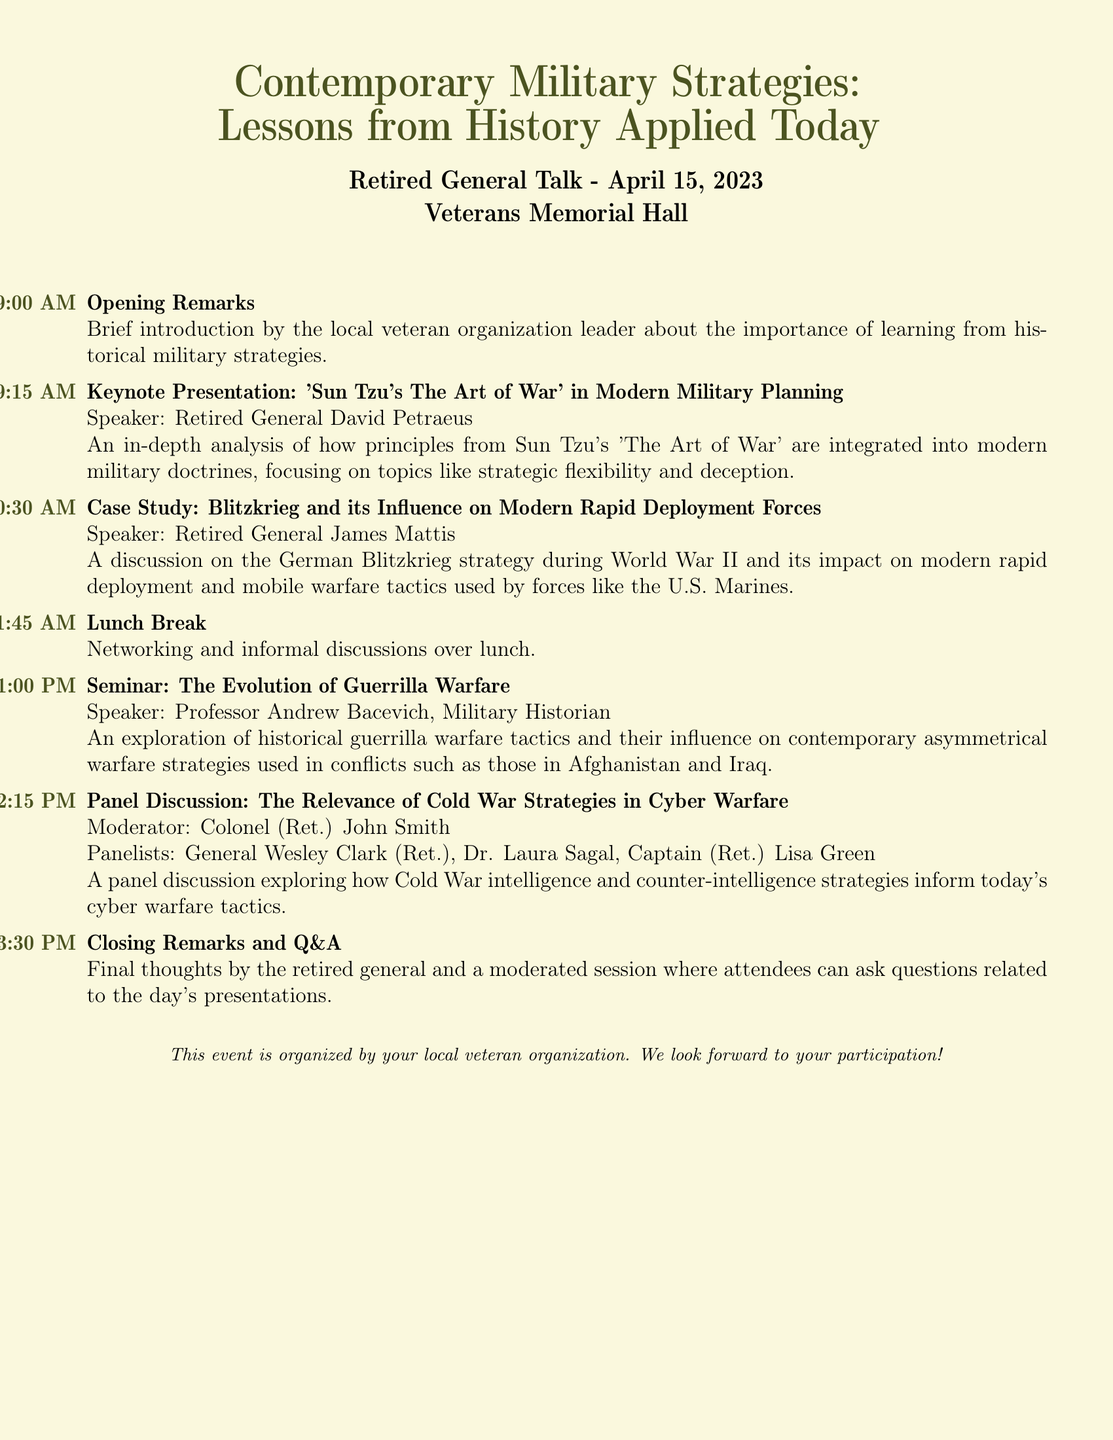What is the date of the event? The date is mentioned prominently in the document, indicating when the event will take place.
Answer: April 15, 2023 Who is the keynote speaker? The document lists the keynote presentation and its speaker, providing specific names associated with each segment.
Answer: Retired General David Petraeus What time does the panel discussion start? The document provides a detailed schedule with exact times for each event.
Answer: 02:15 PM Which strategy is discussed in the case study session? The case study section mentions the specific historical strategy being analyzed during that segment.
Answer: Blitzkrieg Who moderates the panel discussion? The document specifically names the individual responsible for moderating this portion of the event.
Answer: Colonel (Ret.) John Smith What is the subject of the seminar presented by Professor Andrew Bacevich? The seminar description outlines the focus of the presentation, providing a clear topic of discussion.
Answer: The Evolution of Guerrilla Warfare What is provided during the lunch break? The document outlines the purpose of the lunch break, hinting at the activities during that time.
Answer: Networking and informal discussions What is the final activity of the event? The closing section clearly indicates the last scheduled part of the itinerary.
Answer: Closing Remarks and Q&A 